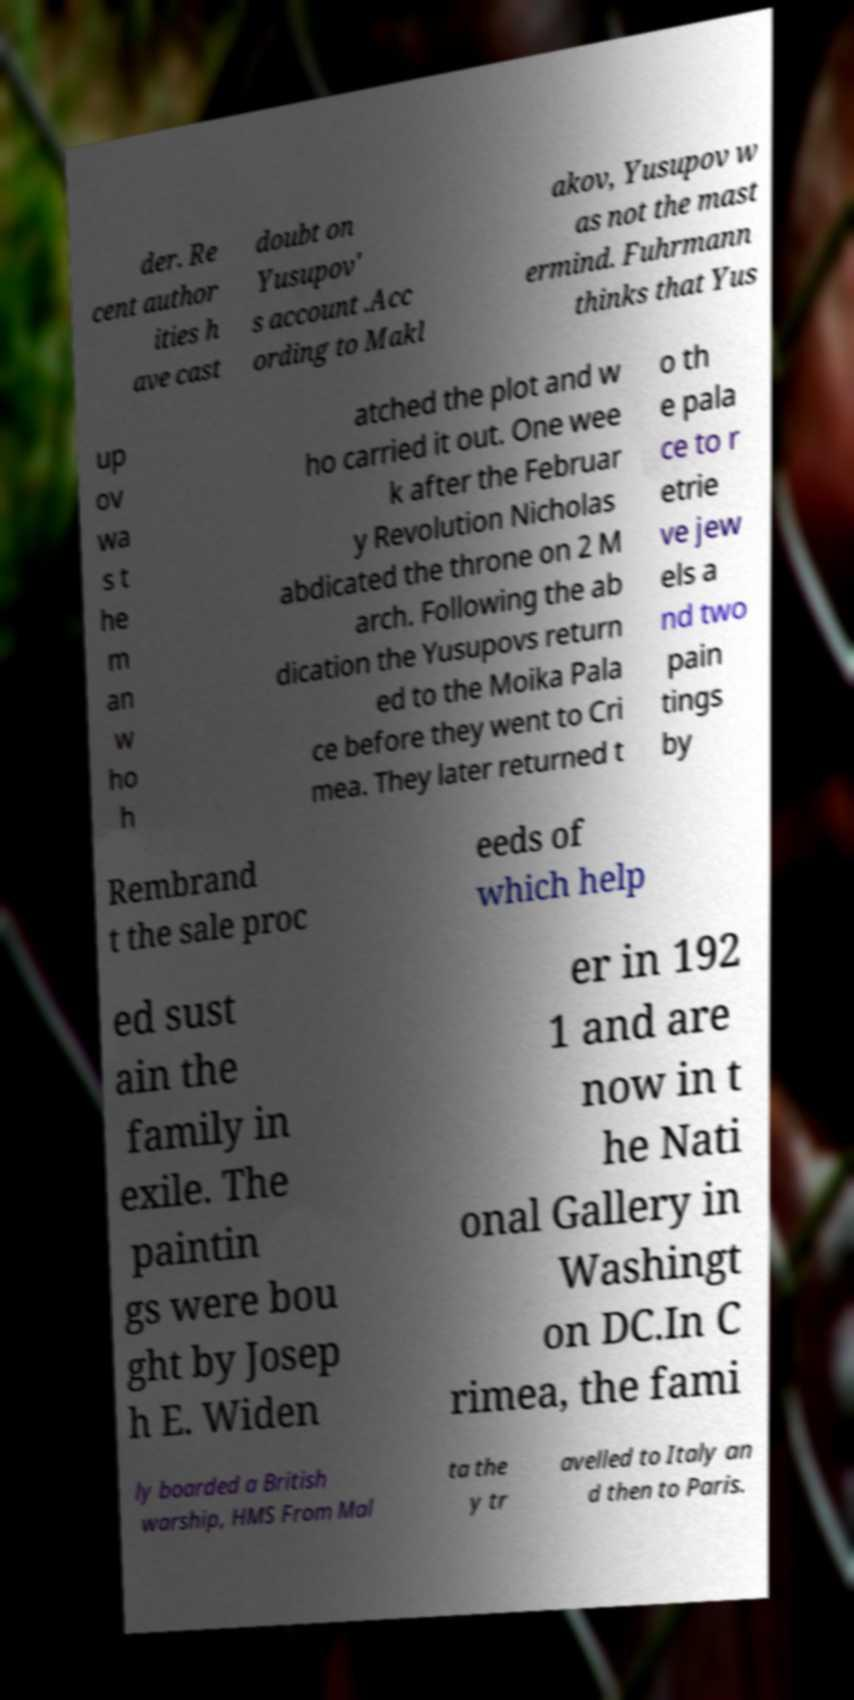Can you accurately transcribe the text from the provided image for me? der. Re cent author ities h ave cast doubt on Yusupov' s account .Acc ording to Makl akov, Yusupov w as not the mast ermind. Fuhrmann thinks that Yus up ov wa s t he m an w ho h atched the plot and w ho carried it out. One wee k after the Februar y Revolution Nicholas abdicated the throne on 2 M arch. Following the ab dication the Yusupovs return ed to the Moika Pala ce before they went to Cri mea. They later returned t o th e pala ce to r etrie ve jew els a nd two pain tings by Rembrand t the sale proc eeds of which help ed sust ain the family in exile. The paintin gs were bou ght by Josep h E. Widen er in 192 1 and are now in t he Nati onal Gallery in Washingt on DC.In C rimea, the fami ly boarded a British warship, HMS From Mal ta the y tr avelled to Italy an d then to Paris. 